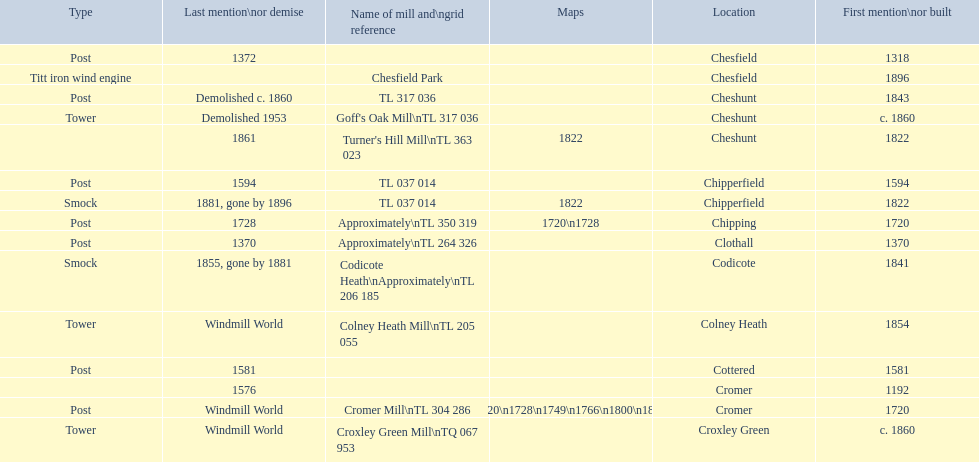How many mills were built or first mentioned after 1800? 8. 